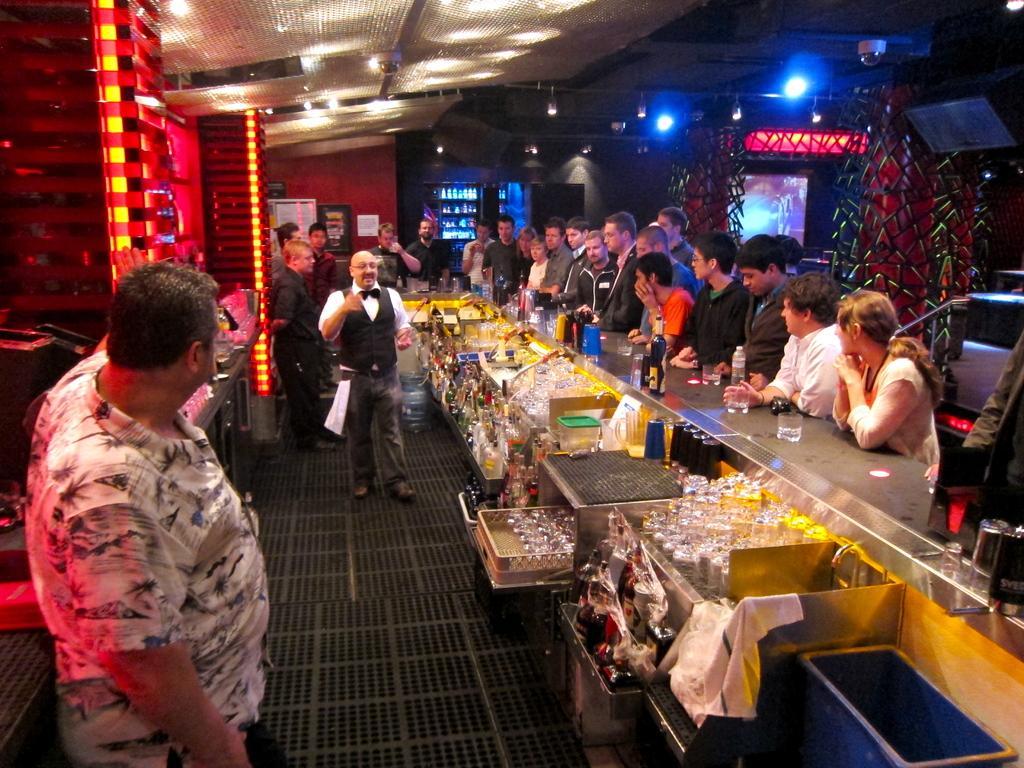Please provide a concise description of this image. In the middle a man is standing, he wore a black coat. In the right side few other people are standing, it looks like a bar. 